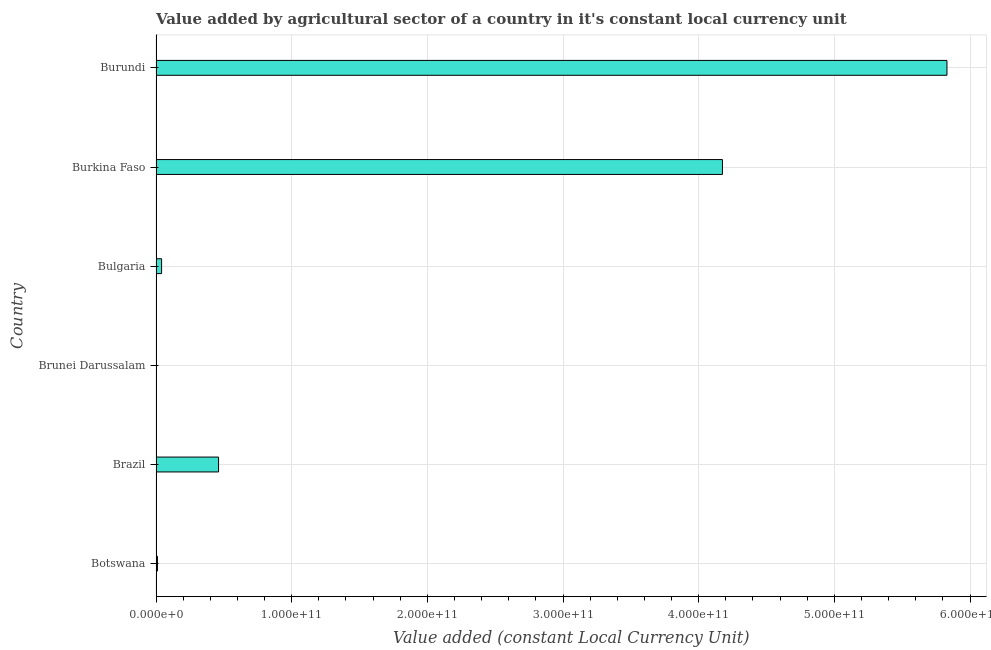Does the graph contain grids?
Provide a succinct answer. Yes. What is the title of the graph?
Provide a succinct answer. Value added by agricultural sector of a country in it's constant local currency unit. What is the label or title of the X-axis?
Offer a terse response. Value added (constant Local Currency Unit). What is the label or title of the Y-axis?
Your response must be concise. Country. What is the value added by agriculture sector in Burundi?
Make the answer very short. 5.83e+11. Across all countries, what is the maximum value added by agriculture sector?
Offer a very short reply. 5.83e+11. Across all countries, what is the minimum value added by agriculture sector?
Your response must be concise. 7.43e+07. In which country was the value added by agriculture sector maximum?
Offer a very short reply. Burundi. In which country was the value added by agriculture sector minimum?
Your answer should be very brief. Brunei Darussalam. What is the sum of the value added by agriculture sector?
Ensure brevity in your answer.  1.05e+12. What is the difference between the value added by agriculture sector in Brunei Darussalam and Bulgaria?
Offer a terse response. -4.03e+09. What is the average value added by agriculture sector per country?
Ensure brevity in your answer.  1.75e+11. What is the median value added by agriculture sector?
Ensure brevity in your answer.  2.51e+1. In how many countries, is the value added by agriculture sector greater than 140000000000 LCU?
Give a very brief answer. 2. What is the ratio of the value added by agriculture sector in Bulgaria to that in Burkina Faso?
Give a very brief answer. 0.01. Is the difference between the value added by agriculture sector in Bulgaria and Burkina Faso greater than the difference between any two countries?
Offer a very short reply. No. What is the difference between the highest and the second highest value added by agriculture sector?
Keep it short and to the point. 1.65e+11. What is the difference between the highest and the lowest value added by agriculture sector?
Offer a terse response. 5.83e+11. How many bars are there?
Your answer should be very brief. 6. Are all the bars in the graph horizontal?
Your answer should be compact. Yes. How many countries are there in the graph?
Make the answer very short. 6. What is the difference between two consecutive major ticks on the X-axis?
Keep it short and to the point. 1.00e+11. Are the values on the major ticks of X-axis written in scientific E-notation?
Ensure brevity in your answer.  Yes. What is the Value added (constant Local Currency Unit) of Botswana?
Provide a succinct answer. 1.06e+09. What is the Value added (constant Local Currency Unit) in Brazil?
Ensure brevity in your answer.  4.61e+1. What is the Value added (constant Local Currency Unit) in Brunei Darussalam?
Give a very brief answer. 7.43e+07. What is the Value added (constant Local Currency Unit) of Bulgaria?
Keep it short and to the point. 4.11e+09. What is the Value added (constant Local Currency Unit) in Burkina Faso?
Give a very brief answer. 4.18e+11. What is the Value added (constant Local Currency Unit) in Burundi?
Your answer should be compact. 5.83e+11. What is the difference between the Value added (constant Local Currency Unit) in Botswana and Brazil?
Your answer should be very brief. -4.50e+1. What is the difference between the Value added (constant Local Currency Unit) in Botswana and Brunei Darussalam?
Provide a short and direct response. 9.82e+08. What is the difference between the Value added (constant Local Currency Unit) in Botswana and Bulgaria?
Provide a short and direct response. -3.05e+09. What is the difference between the Value added (constant Local Currency Unit) in Botswana and Burkina Faso?
Give a very brief answer. -4.16e+11. What is the difference between the Value added (constant Local Currency Unit) in Botswana and Burundi?
Give a very brief answer. -5.82e+11. What is the difference between the Value added (constant Local Currency Unit) in Brazil and Brunei Darussalam?
Offer a terse response. 4.60e+1. What is the difference between the Value added (constant Local Currency Unit) in Brazil and Bulgaria?
Provide a short and direct response. 4.20e+1. What is the difference between the Value added (constant Local Currency Unit) in Brazil and Burkina Faso?
Provide a short and direct response. -3.71e+11. What is the difference between the Value added (constant Local Currency Unit) in Brazil and Burundi?
Your answer should be very brief. -5.37e+11. What is the difference between the Value added (constant Local Currency Unit) in Brunei Darussalam and Bulgaria?
Provide a succinct answer. -4.03e+09. What is the difference between the Value added (constant Local Currency Unit) in Brunei Darussalam and Burkina Faso?
Offer a very short reply. -4.17e+11. What is the difference between the Value added (constant Local Currency Unit) in Brunei Darussalam and Burundi?
Your answer should be compact. -5.83e+11. What is the difference between the Value added (constant Local Currency Unit) in Bulgaria and Burkina Faso?
Offer a very short reply. -4.13e+11. What is the difference between the Value added (constant Local Currency Unit) in Bulgaria and Burundi?
Offer a terse response. -5.79e+11. What is the difference between the Value added (constant Local Currency Unit) in Burkina Faso and Burundi?
Provide a succinct answer. -1.65e+11. What is the ratio of the Value added (constant Local Currency Unit) in Botswana to that in Brazil?
Offer a terse response. 0.02. What is the ratio of the Value added (constant Local Currency Unit) in Botswana to that in Brunei Darussalam?
Make the answer very short. 14.21. What is the ratio of the Value added (constant Local Currency Unit) in Botswana to that in Bulgaria?
Provide a short and direct response. 0.26. What is the ratio of the Value added (constant Local Currency Unit) in Botswana to that in Burkina Faso?
Offer a terse response. 0. What is the ratio of the Value added (constant Local Currency Unit) in Botswana to that in Burundi?
Your answer should be compact. 0. What is the ratio of the Value added (constant Local Currency Unit) in Brazil to that in Brunei Darussalam?
Your response must be concise. 620.43. What is the ratio of the Value added (constant Local Currency Unit) in Brazil to that in Bulgaria?
Offer a terse response. 11.22. What is the ratio of the Value added (constant Local Currency Unit) in Brazil to that in Burkina Faso?
Ensure brevity in your answer.  0.11. What is the ratio of the Value added (constant Local Currency Unit) in Brazil to that in Burundi?
Your answer should be compact. 0.08. What is the ratio of the Value added (constant Local Currency Unit) in Brunei Darussalam to that in Bulgaria?
Your answer should be compact. 0.02. What is the ratio of the Value added (constant Local Currency Unit) in Brunei Darussalam to that in Burkina Faso?
Provide a short and direct response. 0. What is the ratio of the Value added (constant Local Currency Unit) in Bulgaria to that in Burundi?
Keep it short and to the point. 0.01. What is the ratio of the Value added (constant Local Currency Unit) in Burkina Faso to that in Burundi?
Give a very brief answer. 0.72. 